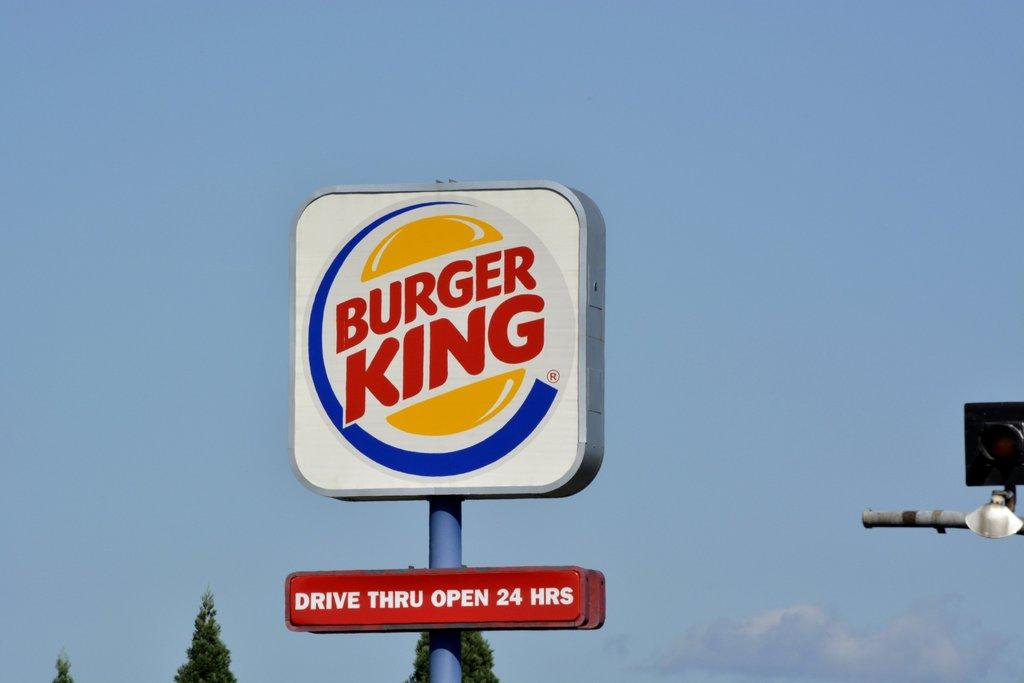<image>
Provide a brief description of the given image. a Burger King sign with a message on the bottom of it 